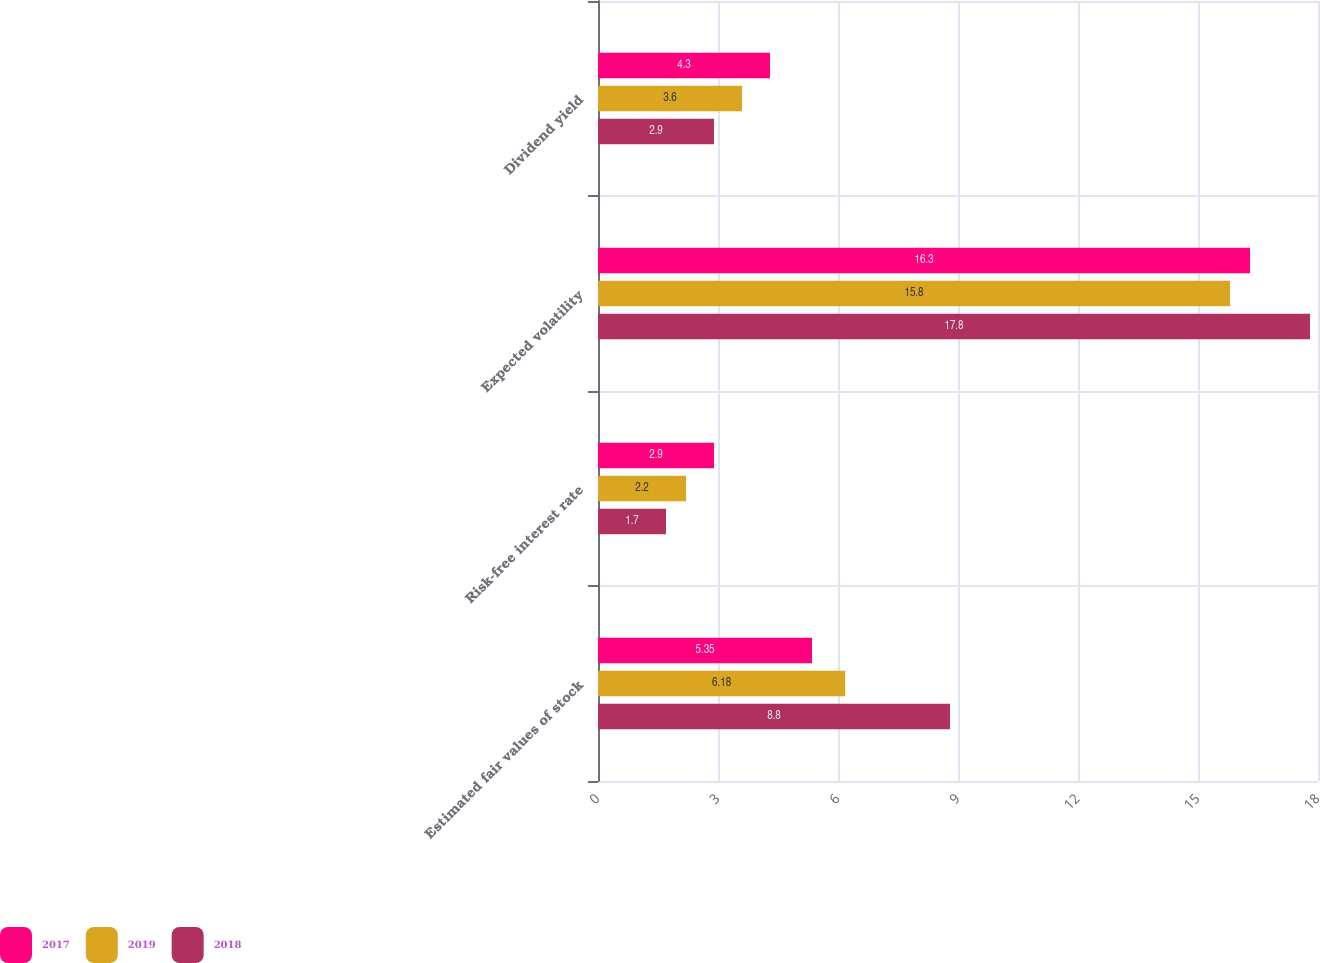<chart> <loc_0><loc_0><loc_500><loc_500><stacked_bar_chart><ecel><fcel>Estimated fair values of stock<fcel>Risk-free interest rate<fcel>Expected volatility<fcel>Dividend yield<nl><fcel>2017<fcel>5.35<fcel>2.9<fcel>16.3<fcel>4.3<nl><fcel>2019<fcel>6.18<fcel>2.2<fcel>15.8<fcel>3.6<nl><fcel>2018<fcel>8.8<fcel>1.7<fcel>17.8<fcel>2.9<nl></chart> 